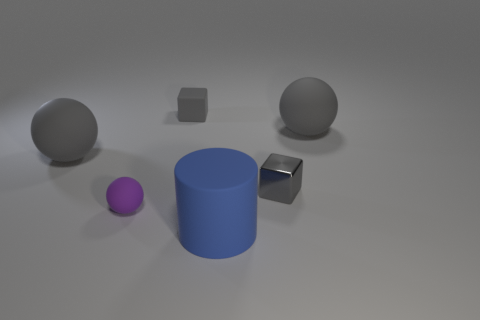Does the small gray cube that is right of the large matte cylinder have the same material as the purple object?
Give a very brief answer. No. What is the color of the other small thing that is the same shape as the tiny gray matte thing?
Your answer should be compact. Gray. Is there any other thing that is the same shape as the small purple rubber object?
Provide a succinct answer. Yes. There is a tiny rubber thing on the right side of the purple ball; does it have the same shape as the small thing on the right side of the gray matte cube?
Ensure brevity in your answer.  Yes. What is the size of the other gray object that is the same shape as the metal thing?
Ensure brevity in your answer.  Small. Do the metal cube and the blue cylinder have the same size?
Keep it short and to the point. No. Is there a blue matte thing of the same size as the gray rubber cube?
Your answer should be compact. No. What is the tiny gray cube that is right of the big blue object made of?
Ensure brevity in your answer.  Metal. What is the color of the small ball that is the same material as the large blue cylinder?
Keep it short and to the point. Purple. How many matte things are blue cylinders or tiny gray objects?
Keep it short and to the point. 2. 